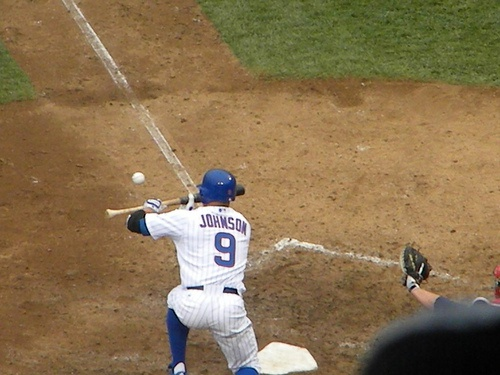Describe the objects in this image and their specific colors. I can see people in gray, lavender, darkgray, and navy tones, baseball glove in gray and black tones, baseball bat in gray, black, and tan tones, and sports ball in gray, ivory, and tan tones in this image. 